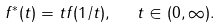Convert formula to latex. <formula><loc_0><loc_0><loc_500><loc_500>f ^ { * } ( t ) = t f ( 1 / t ) , \ \ t \in ( 0 , \infty ) .</formula> 